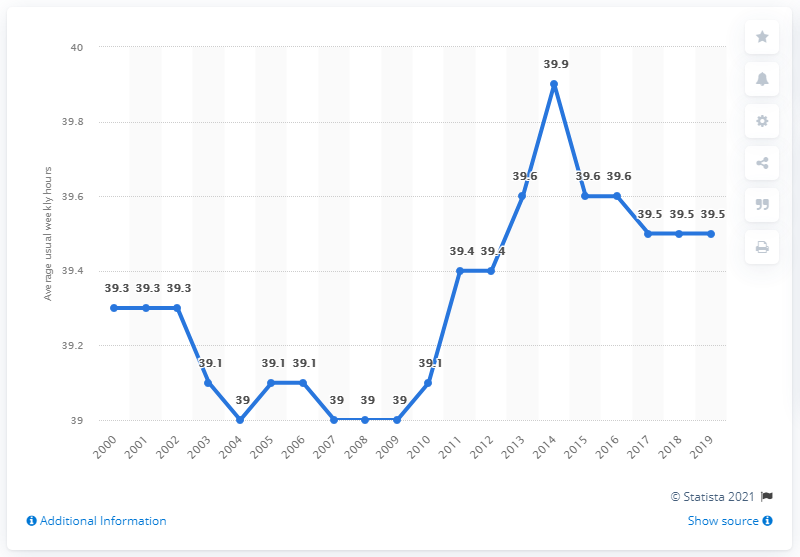Outline some significant characteristics in this image. The average weekly hours worked on the main job in Portugal increased from 39.9 hours in 2000 to 40.4 hours in 2019. In 2019, the average weekly hours worked in Portugal was 39.5 hours. 